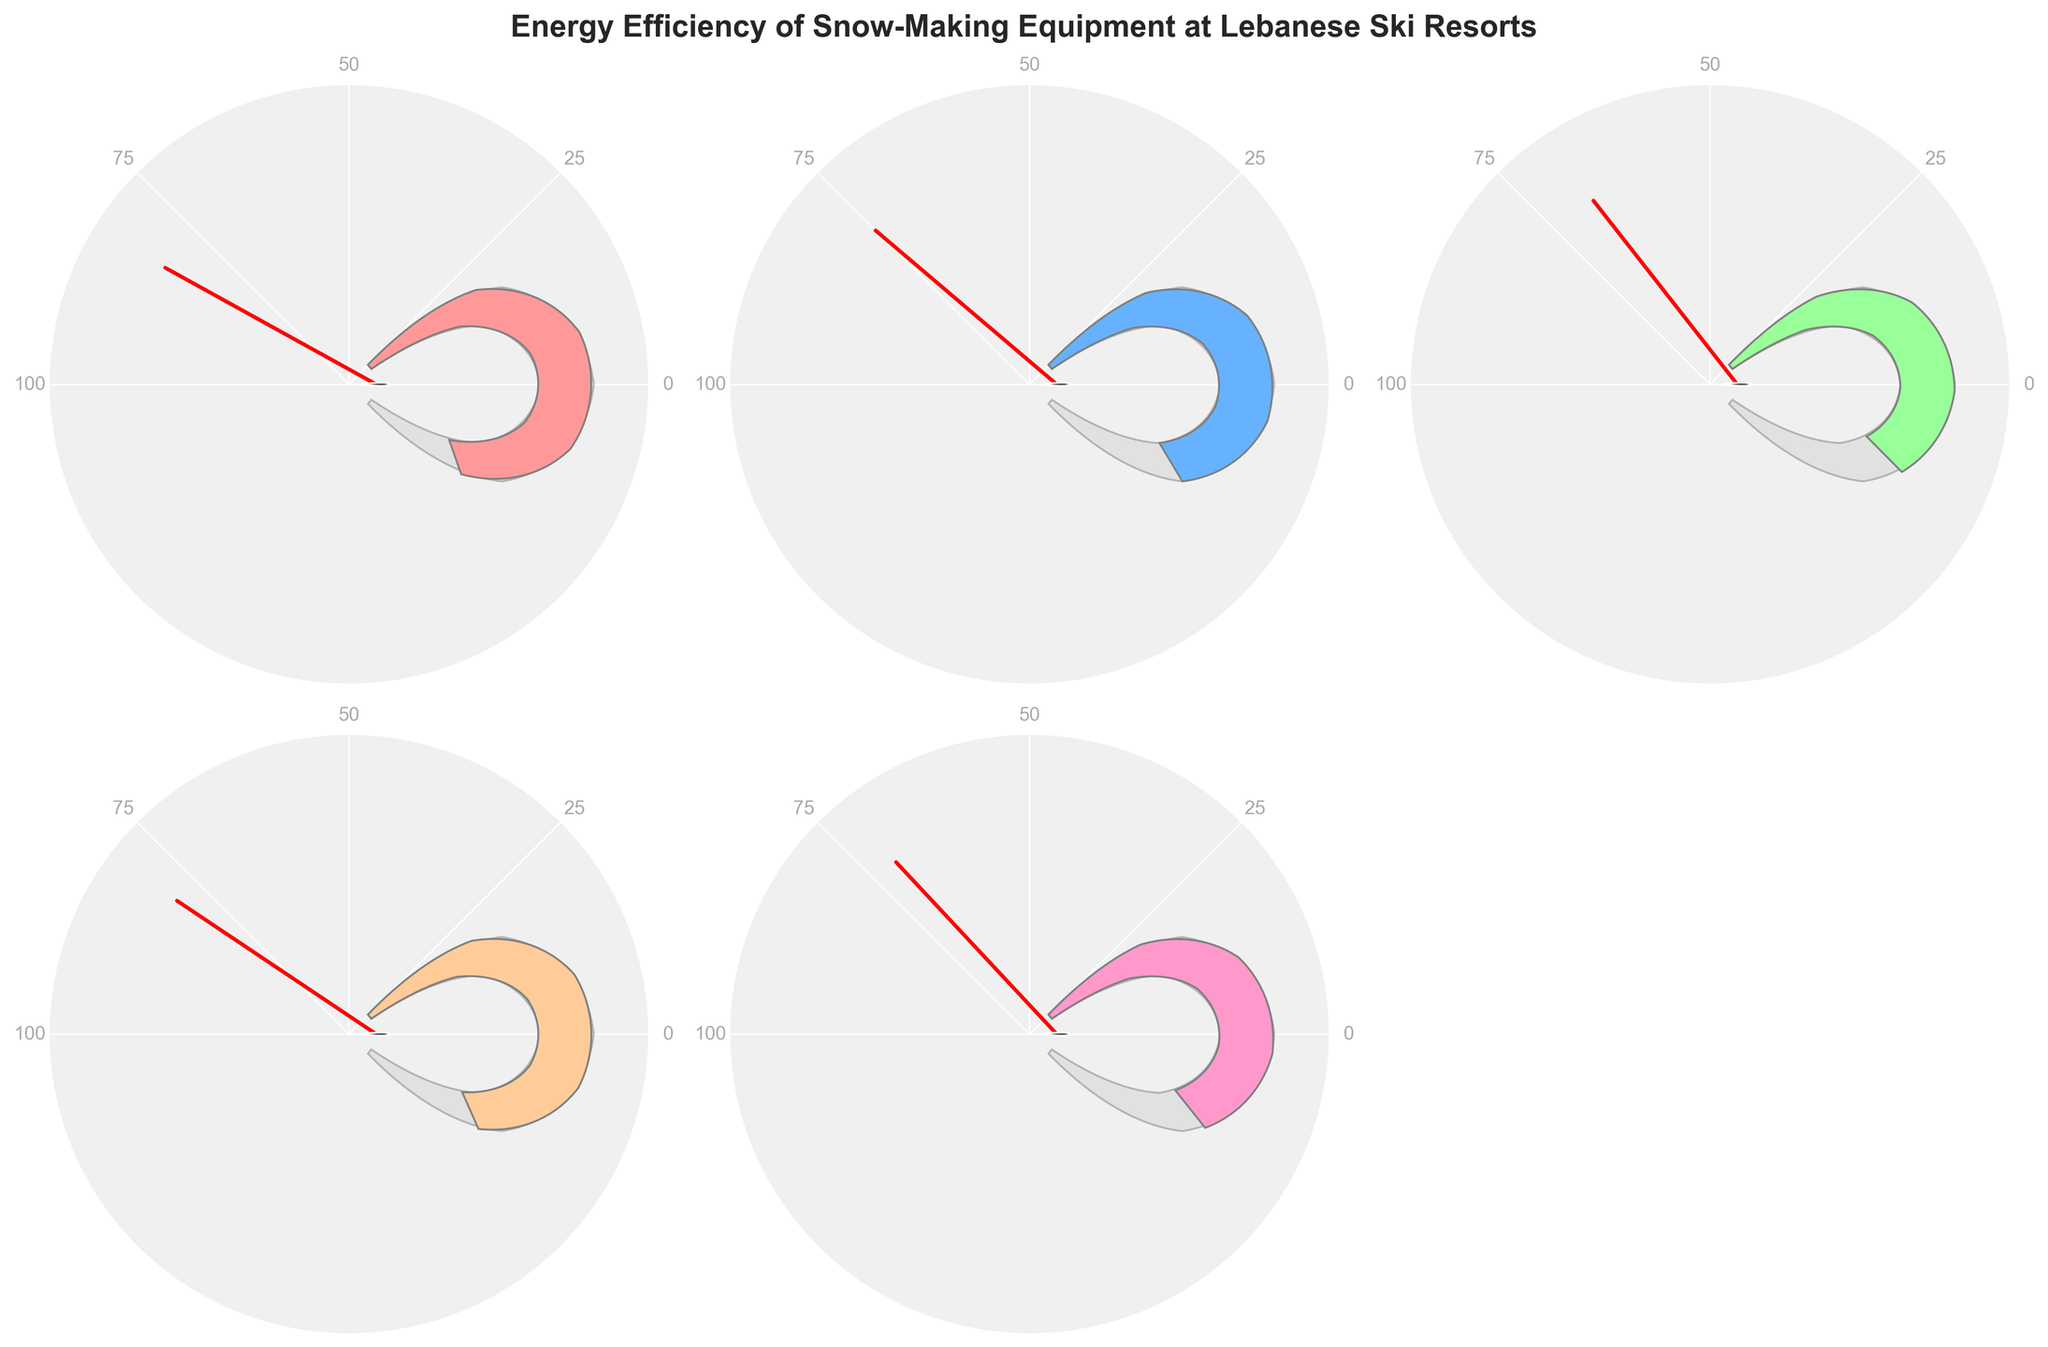What is the title of the figure? The title is displayed at the top of the figure in a larger and bold font.
Answer: Energy Efficiency of Snow-Making Equipment at Lebanese Ski Resorts How many ski resorts are included in the figure? There are gauge charts for each of the ski resorts. By counting the number of gauge charts, we see that there are 5.
Answer: 5 Which ski resort has the highest efficiency percentage? By checking the efficiency percentages labeled on each gauge chart, we see that Faraya Mzaar has the highest percentage of 82%.
Answer: Faraya Mzaar What color is used to represent Laqlouq in the figure? The colors of each gauge chart signify different resorts. The Laqlouq gauge chart is represented with a green color.
Answer: Green What is the combined efficiency percentage for Faqra and Zaarour? Faqra has an efficiency of 79%, and Zaarour has 71%. Adding these two percentages together gives 150%.
Answer: 150% What is the average efficiency percentage of all the ski resorts? The efficiencies are 82, 75, 68, 79, and 71. To find the average, sum these values to get 375 and then divide by the number of resorts (5). So, 375 / 5 = 75%.
Answer: 75% Which ski resort falls closest to the industry standard in terms of efficiency percentage? The industry standard is 100%. Faraya Mzaar with an efficiency of 82% is the closest to this standard.
Answer: Faraya Mzaar How does the energy efficiency of The Cedars compare to Laqlouq? The Cedars has an efficiency of 75%, while Laqlouq has 68%. Since 75% > 68%, The Cedars is more efficient than Laqlouq.
Answer: The Cedars is more efficient Of the five ski resorts, which one has the lowest efficiency percentage? By looking at the efficiency percentages labeled on each gauge chart, Laqlouq has the lowest percentage of 68%.
Answer: Laqlouq By how much does Faraya Mzaar's efficiency percentage exceed Zaarour's? Faraya Mzaar's efficiency is 82%, and Zaarour's is 71%. Subtracting these gives 82% - 71% = 11%.
Answer: 11% 